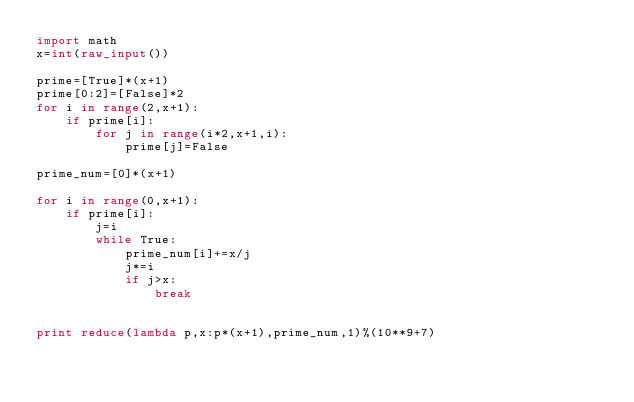<code> <loc_0><loc_0><loc_500><loc_500><_Python_>import math
x=int(raw_input())

prime=[True]*(x+1)
prime[0:2]=[False]*2
for i in range(2,x+1):
    if prime[i]:
        for j in range(i*2,x+1,i):
            prime[j]=False

prime_num=[0]*(x+1)

for i in range(0,x+1):
    if prime[i]:
        j=i
        while True:
            prime_num[i]+=x/j
            j*=i
            if j>x:
                break


print reduce(lambda p,x:p*(x+1),prime_num,1)%(10**9+7)

</code> 